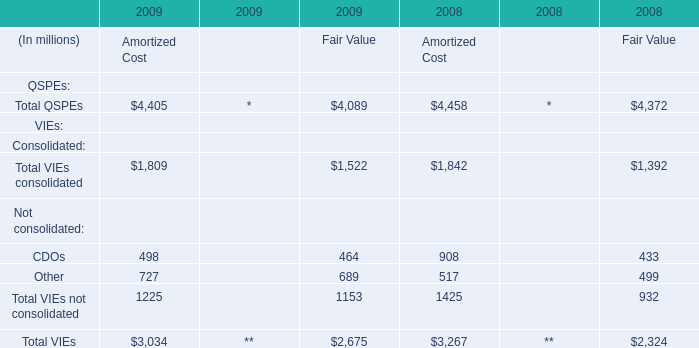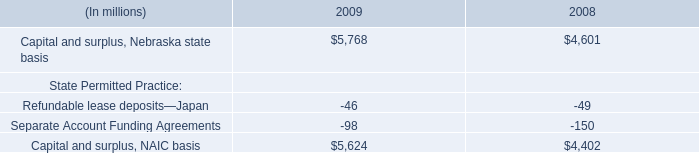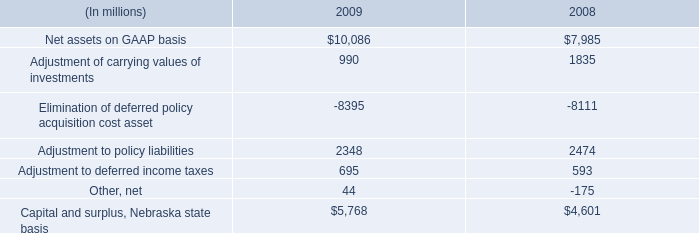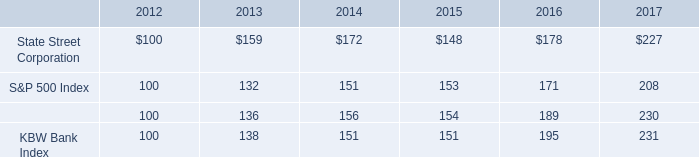If Amortized Costdevelops with the same increasing rate in 2009, what will it reach in 2010? (in million) 
Computations: (exp((1 - 0.047216157205240174) * 2))
Answer: 9507.35852. 